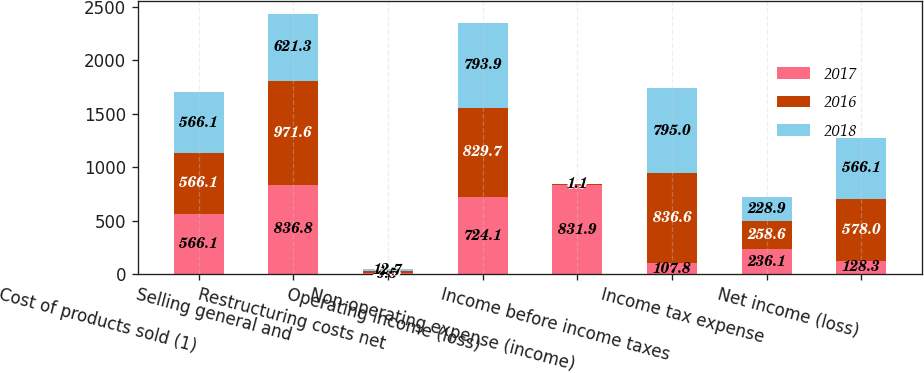Convert chart to OTSL. <chart><loc_0><loc_0><loc_500><loc_500><stacked_bar_chart><ecel><fcel>Cost of products sold (1)<fcel>Selling general and<fcel>Restructuring costs net<fcel>Operating income (loss)<fcel>Non-operating expense (income)<fcel>Income before income taxes<fcel>Income tax expense<fcel>Net income (loss)<nl><fcel>2017<fcel>566.1<fcel>836.8<fcel>9.5<fcel>724.1<fcel>831.9<fcel>107.8<fcel>236.1<fcel>128.3<nl><fcel>2016<fcel>566.1<fcel>971.6<fcel>24.3<fcel>829.7<fcel>6.9<fcel>836.6<fcel>258.6<fcel>578<nl><fcel>2018<fcel>566.1<fcel>621.3<fcel>12.7<fcel>793.9<fcel>1.1<fcel>795<fcel>228.9<fcel>566.1<nl></chart> 